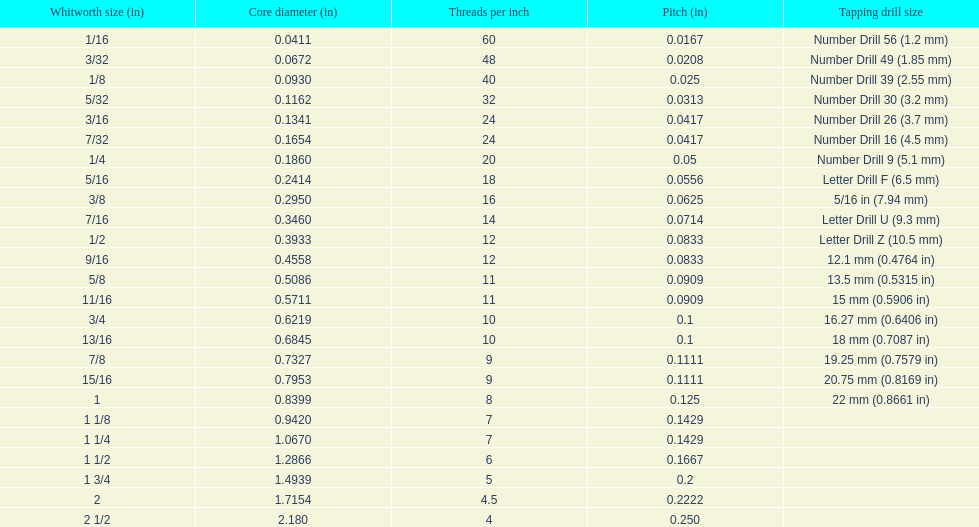Which whitworth size is the only one with 5 threads per inch? 1 3/4. 